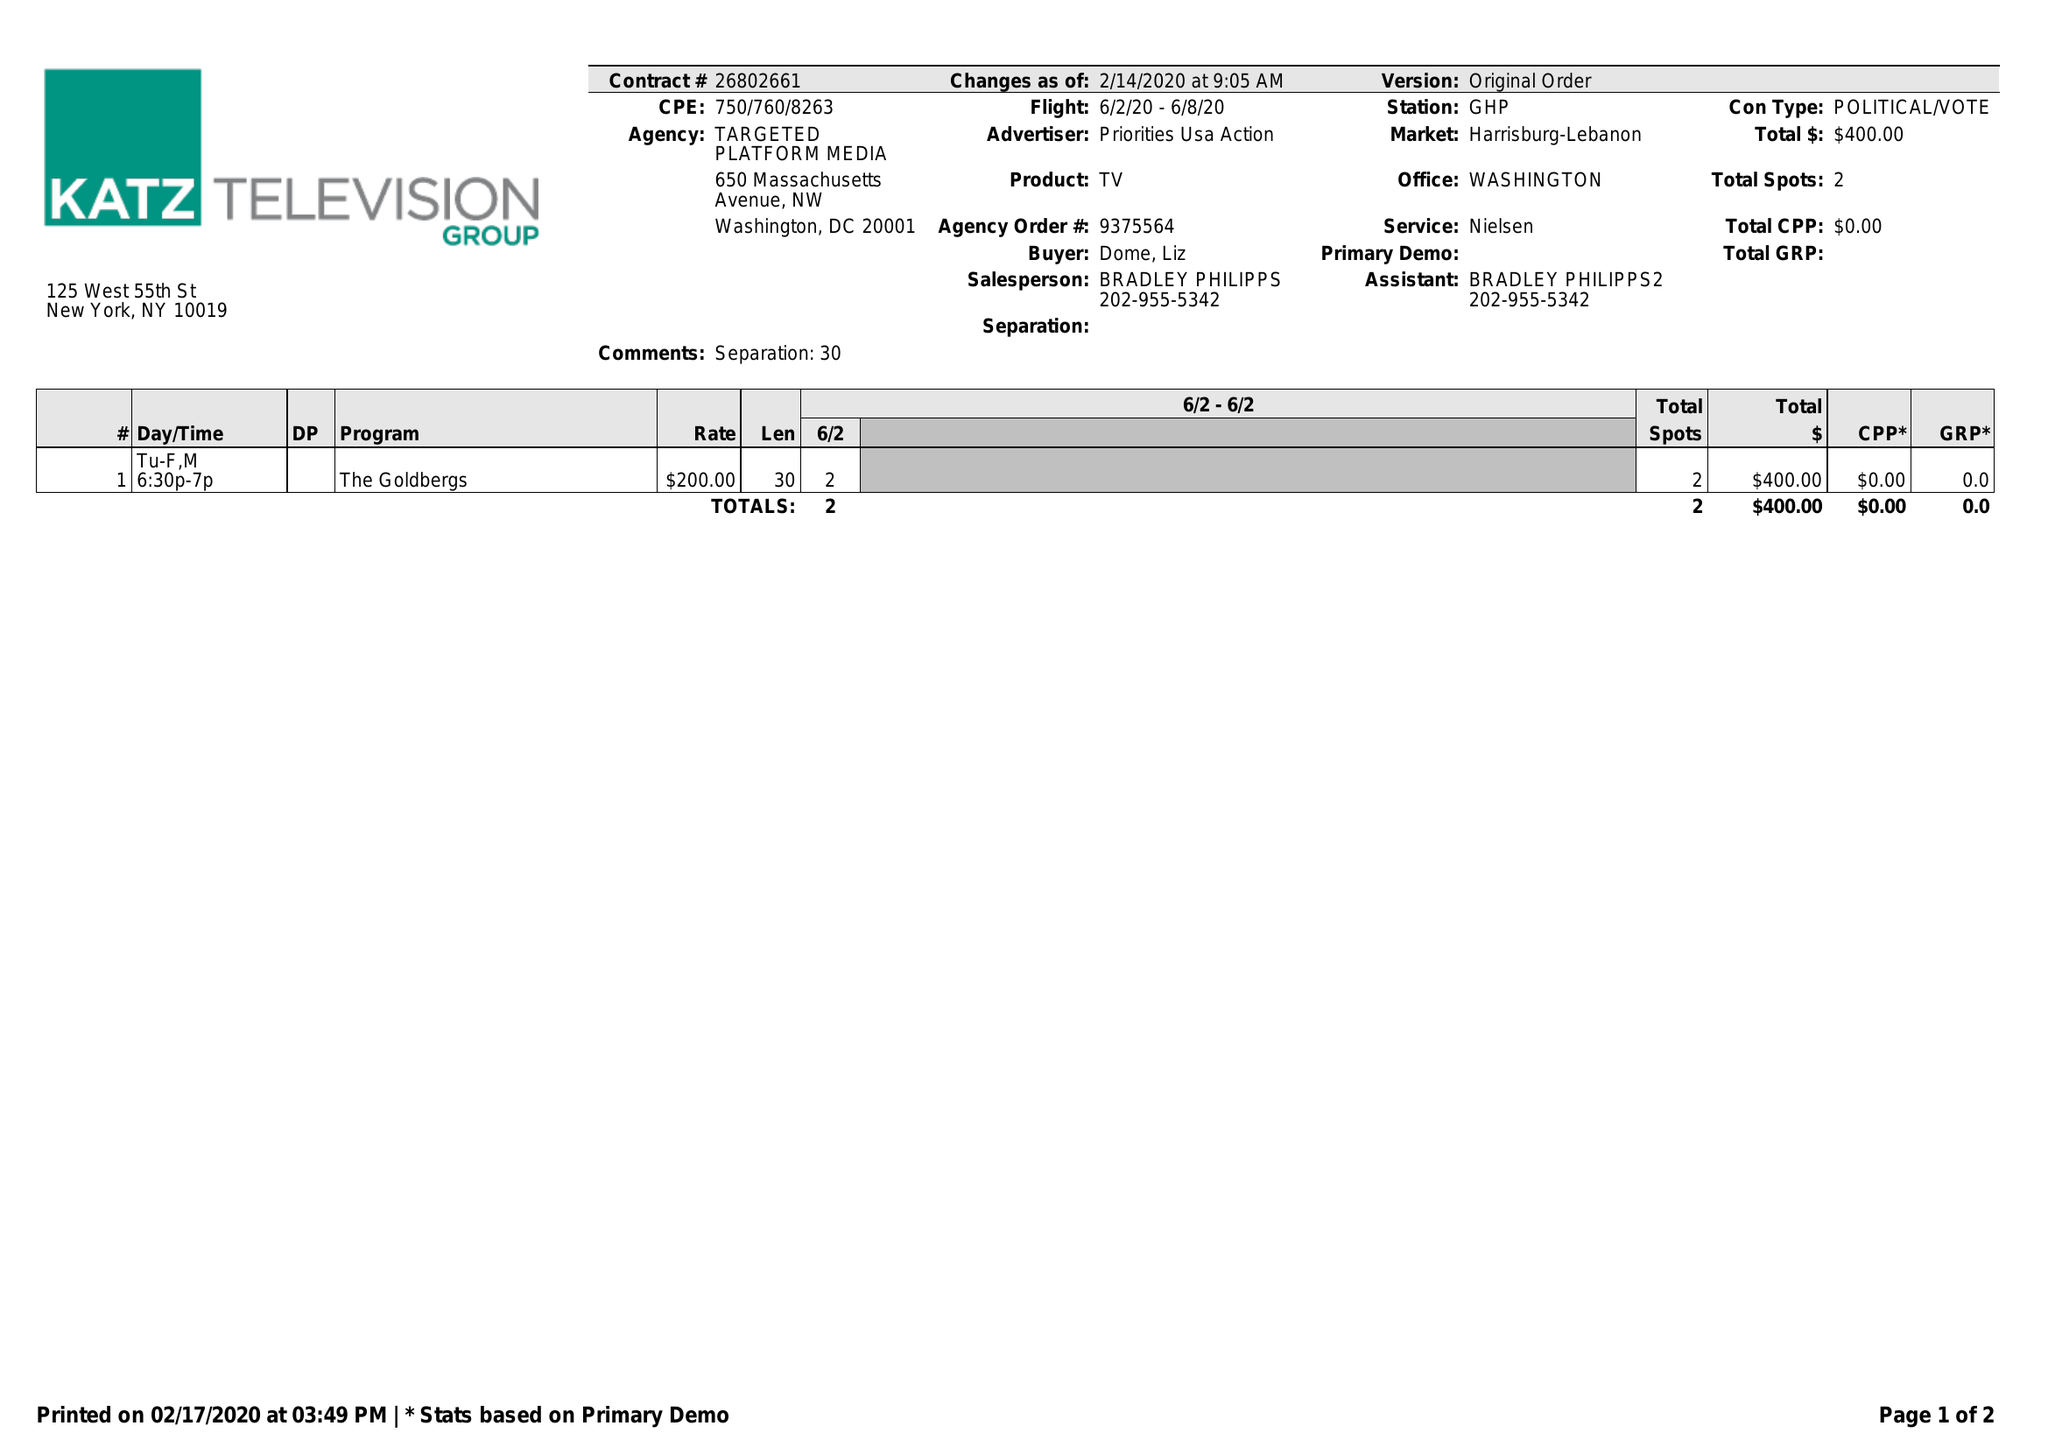What is the value for the flight_to?
Answer the question using a single word or phrase. 06/08/20 